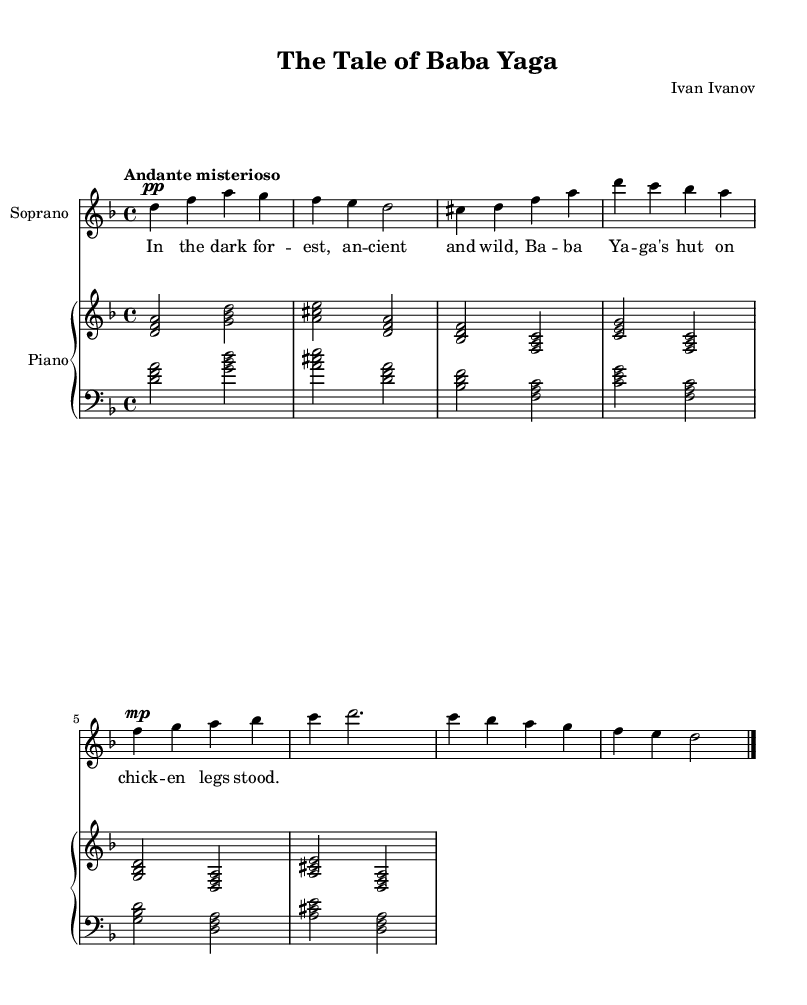What is the key signature of this music? The key signature is D minor, which is indicated by one flat in the key signature.
Answer: D minor What is the time signature of this music? The time signature is 4/4, as shown at the beginning of the score.
Answer: 4/4 What is the tempo marking for this piece? The tempo marking is "Andante misterioso," which suggests a moderate, mysterious pace.
Answer: Andante misterioso Who is the composer of this work? The composer's name is stated in the header of the score as Ivan Ivanov.
Answer: Ivan Ivanov What is the title of this work? The title of the composition is provided in the header as "The Tale of Baba Yaga."
Answer: The Tale of Baba Yaga How many measures are in the soprano part? The soprano part contains a total of eight measures, as counted from the notation provided.
Answer: Eight measures What dynamic marking is indicated at the beginning of the soprano part? The dynamic marking for the soprano part at the beginning is pianissimo, indicated by 'pp'.
Answer: Pianissimo 